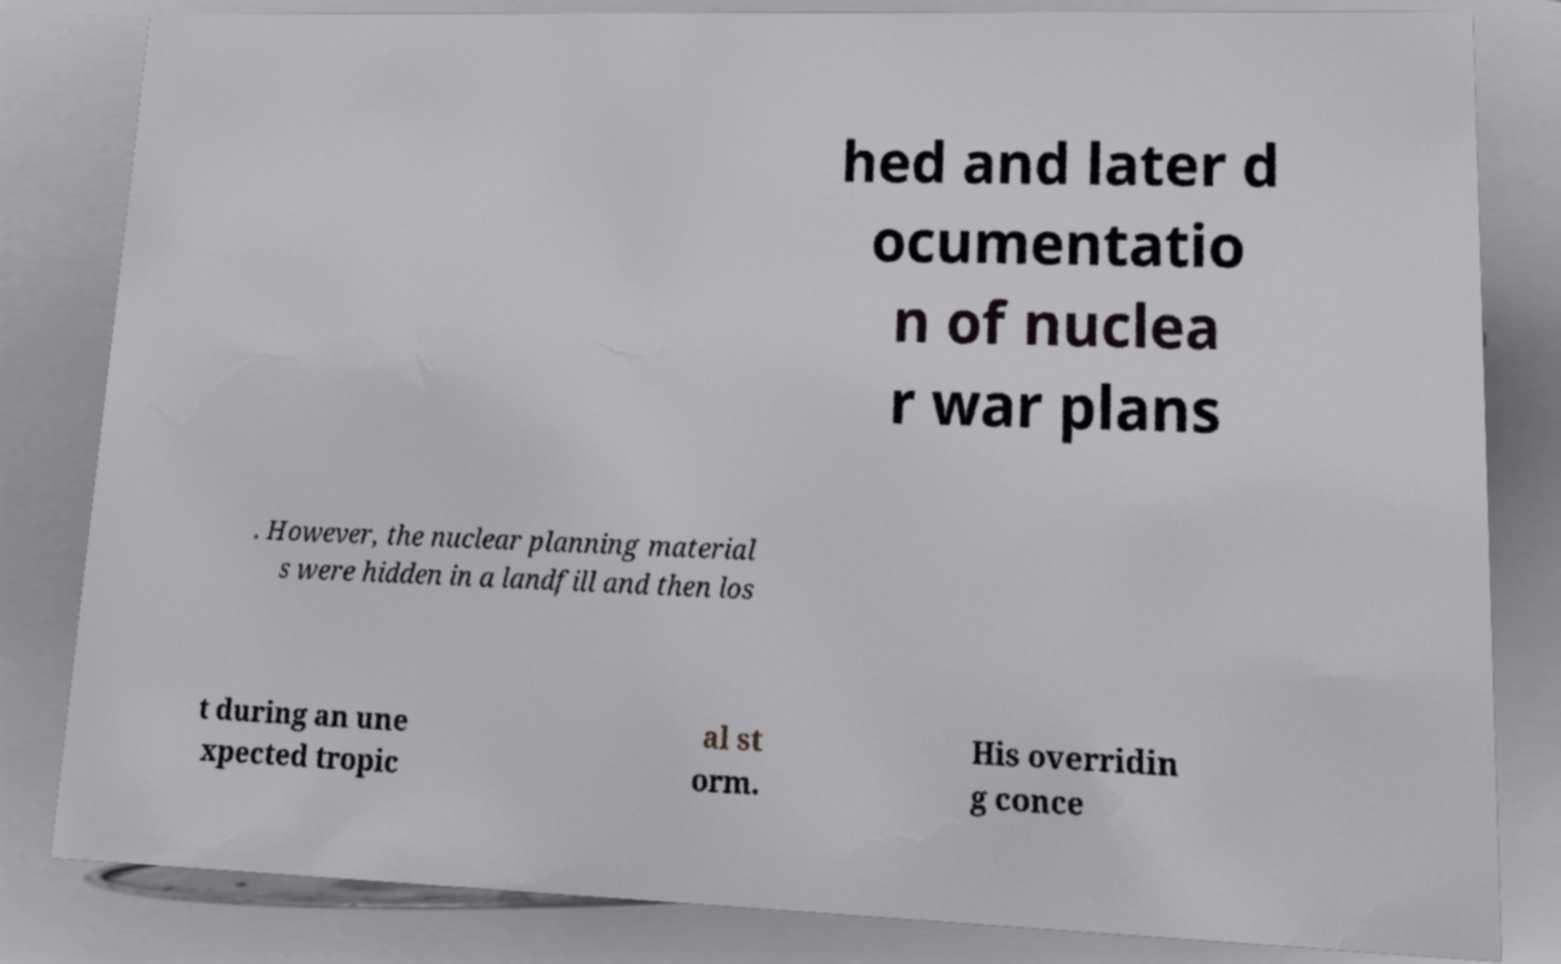There's text embedded in this image that I need extracted. Can you transcribe it verbatim? hed and later d ocumentatio n of nuclea r war plans . However, the nuclear planning material s were hidden in a landfill and then los t during an une xpected tropic al st orm. His overridin g conce 